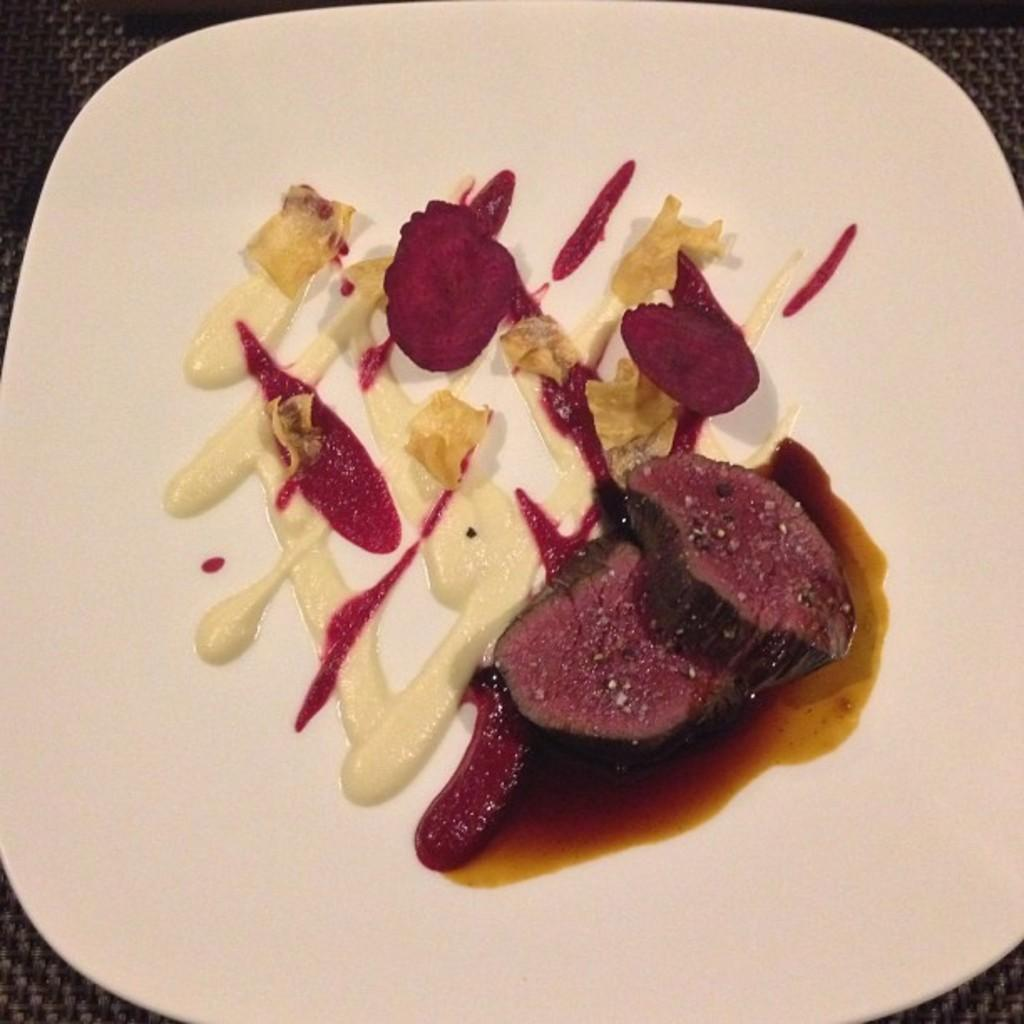What is the main subject of the image? There is a food item in the image. How is the food item presented in the image? The food item is on a white color plate. How many birds are sitting on the plate with the food item in the image? There are no birds present in the image; it only features a food item on a white color plate. Are the brothers of the person who prepared the food item visible in the image? There is no reference to any person or their brothers in the image, so it cannot be determined if they are present. 